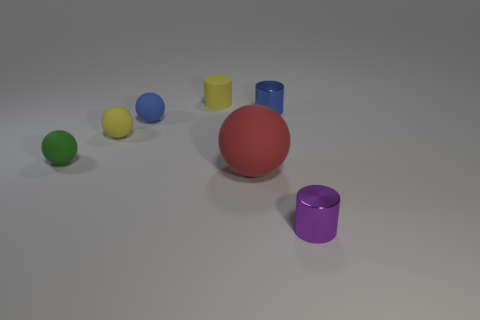Subtract all blue spheres. How many spheres are left? 3 Subtract all small shiny cylinders. How many cylinders are left? 1 Subtract 1 cylinders. How many cylinders are left? 2 Subtract all gray balls. Subtract all gray cubes. How many balls are left? 4 Add 3 small green matte objects. How many objects exist? 10 Subtract 0 gray cubes. How many objects are left? 7 Subtract all balls. How many objects are left? 3 Subtract all green spheres. Subtract all green rubber balls. How many objects are left? 5 Add 3 purple objects. How many purple objects are left? 4 Add 6 tiny blue spheres. How many tiny blue spheres exist? 7 